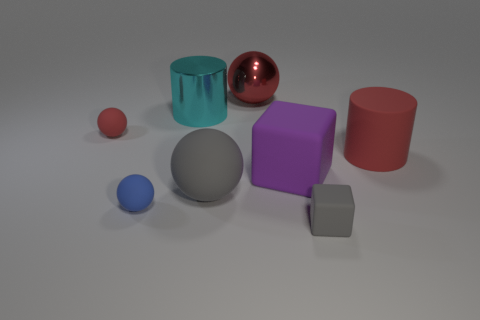Add 1 large purple rubber balls. How many objects exist? 9 Subtract all cubes. How many objects are left? 6 Subtract 1 red spheres. How many objects are left? 7 Subtract all large gray matte objects. Subtract all large shiny cylinders. How many objects are left? 6 Add 1 purple cubes. How many purple cubes are left? 2 Add 3 tiny cylinders. How many tiny cylinders exist? 3 